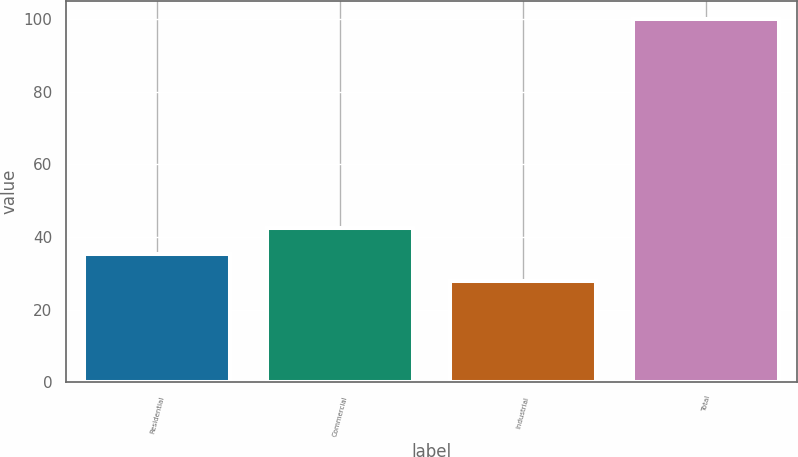Convert chart to OTSL. <chart><loc_0><loc_0><loc_500><loc_500><bar_chart><fcel>Residential<fcel>Commercial<fcel>Industrial<fcel>Total<nl><fcel>35.2<fcel>42.4<fcel>28<fcel>100<nl></chart> 